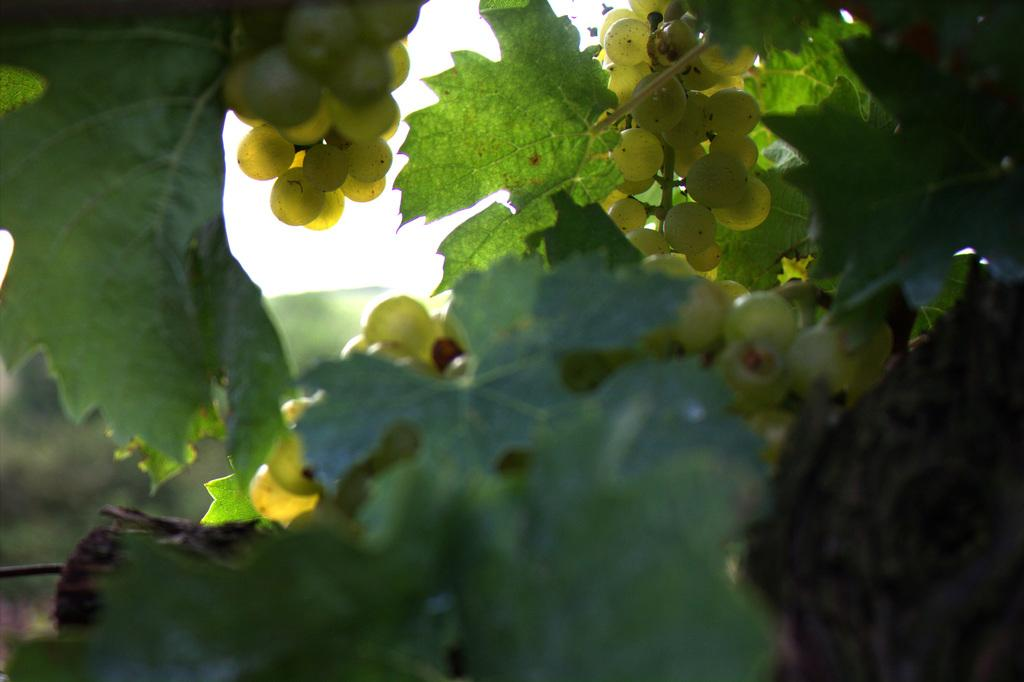What type of fruit is visible in the image? There are grapes in the image. Where are the grapes located? The grapes are on a grape plant. Can you see the grapes talking to each other in the image? There is no indication in the image that the grapes are talking to each other, as they are inanimate objects. 